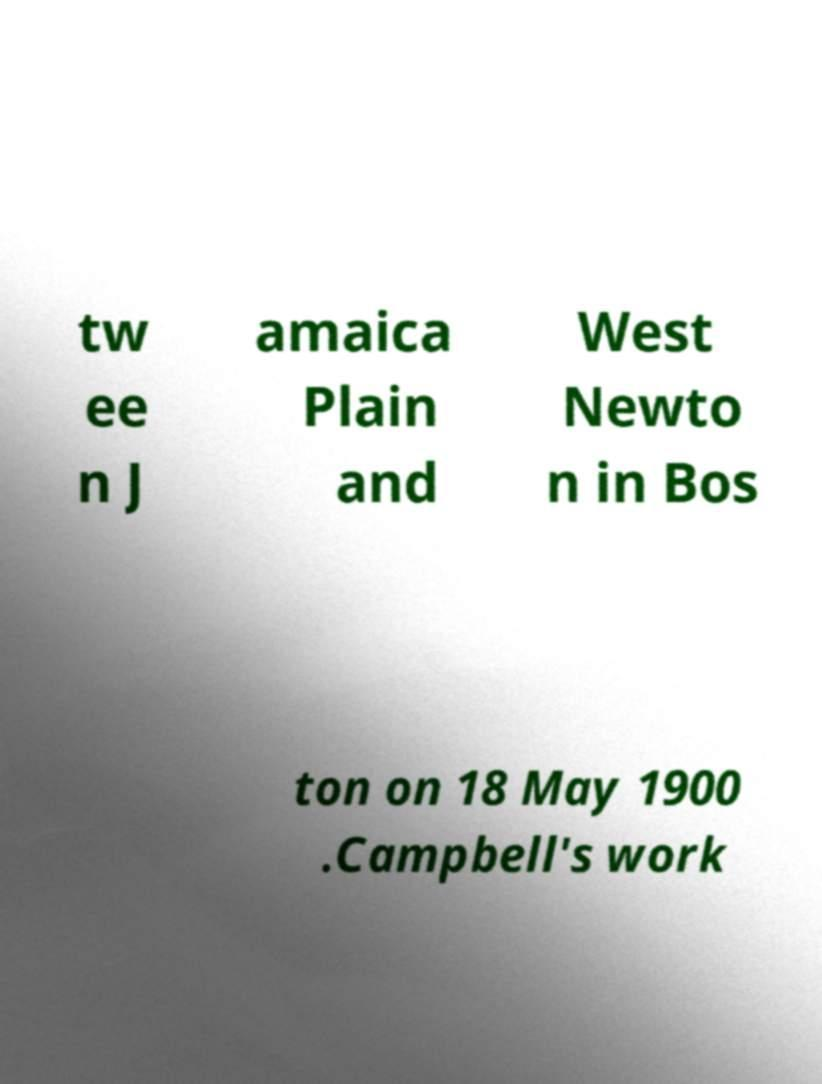Please identify and transcribe the text found in this image. tw ee n J amaica Plain and West Newto n in Bos ton on 18 May 1900 .Campbell's work 